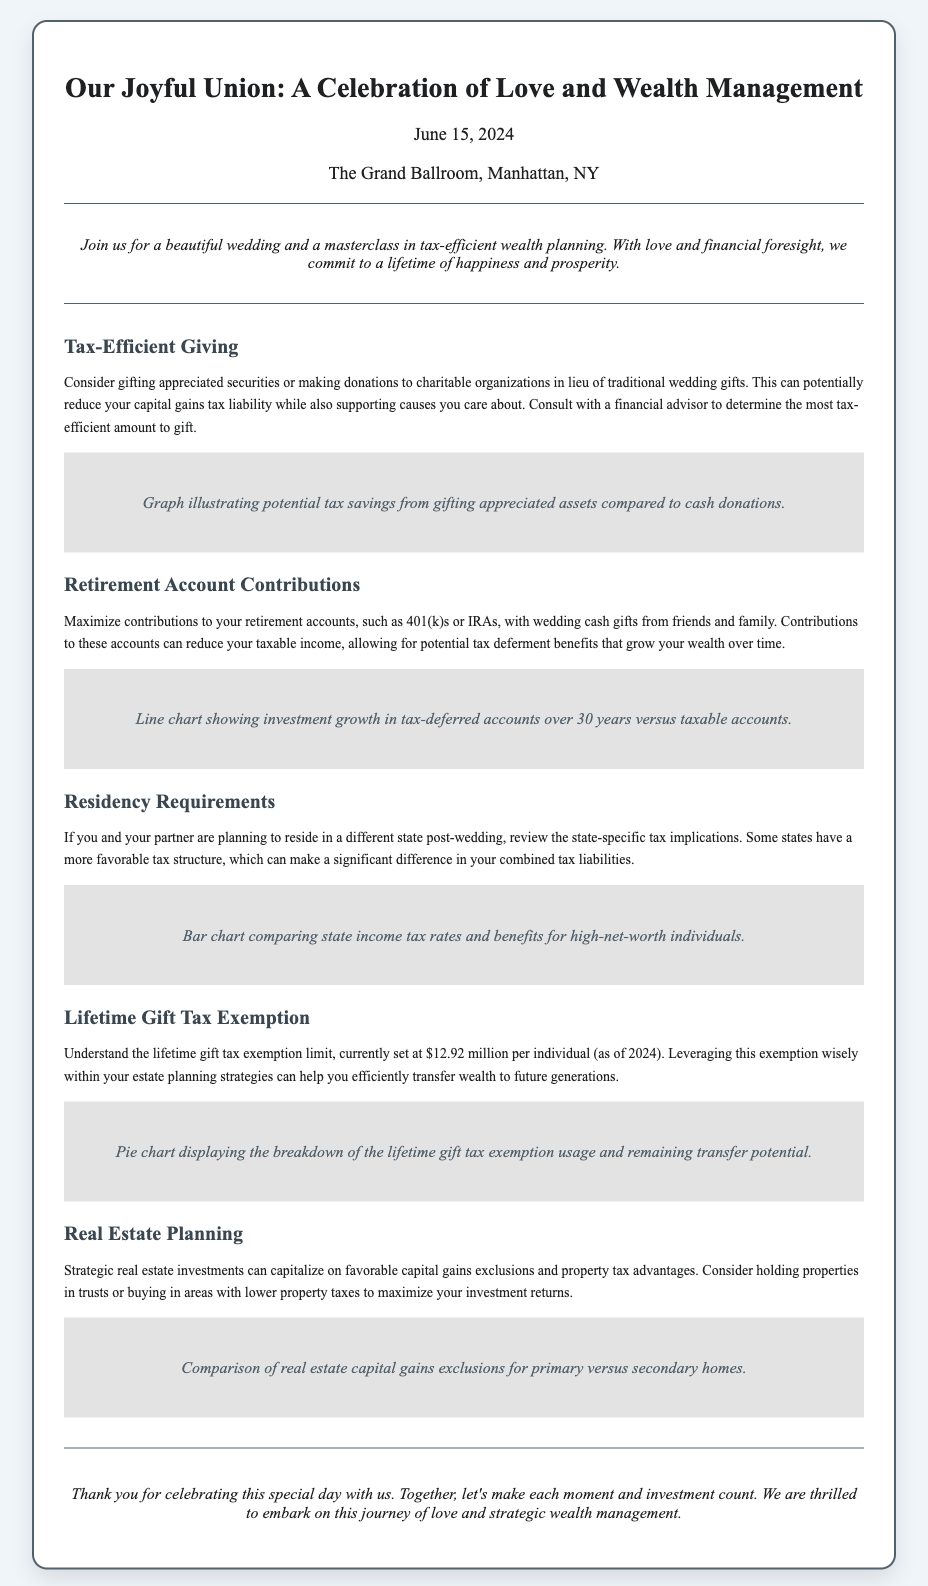What is the wedding date? The wedding date is mentioned in the section that presents the date and location details of the invitation.
Answer: June 15, 2024 Where is the wedding taking place? The location of the wedding is included in the invitation, specifically under the date location section.
Answer: The Grand Ballroom, Manhattan, NY What is one tax-efficient gifting strategy mentioned? The strategy is outlined in the section titled "Tax-Efficient Giving," providing details on the gifting options.
Answer: Gifting appreciated securities What is the exemption limit for lifetime gifts as of 2024? The exemption limit is stated clearly in the section discussing the lifetime gift tax exemption.
Answer: $12.92 million What should be maximized with wedding cash gifts? The recommendation is found in the section regarding retirement account contributions.
Answer: Contributions to retirement accounts Which state consideration is important for residency? The section on residency requirements highlights the impact of state-specific factors on taxes.
Answer: State-specific tax implications What investment type is discussed under Real Estate Planning? The section mentions strategic investments that can capitalize on tax advantages.
Answer: Real estate investments What type of chart illustrates investment growth in tax-deferred accounts? The specific type of chart used to visualize this information is noted in the section about retirement accounts.
Answer: Line chart 